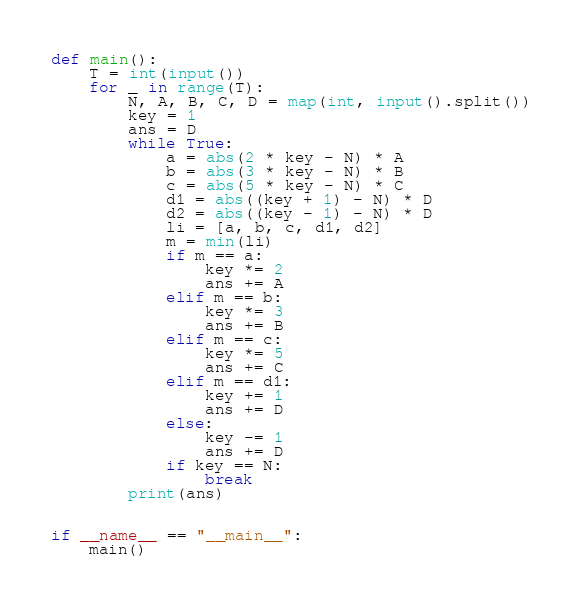<code> <loc_0><loc_0><loc_500><loc_500><_Python_>def main():
    T = int(input())
    for _ in range(T):
        N, A, B, C, D = map(int, input().split())
        key = 1
        ans = D
        while True:
            a = abs(2 * key - N) * A
            b = abs(3 * key - N) * B
            c = abs(5 * key - N) * C
            d1 = abs((key + 1) - N) * D
            d2 = abs((key - 1) - N) * D
            li = [a, b, c, d1, d2]
            m = min(li)
            if m == a:
                key *= 2
                ans += A
            elif m == b:
                key *= 3
                ans += B
            elif m == c:
                key *= 5
                ans += C
            elif m == d1:
                key += 1
                ans += D
            else:
                key -= 1
                ans += D
            if key == N:
                break
        print(ans)


if __name__ == "__main__":
    main()
</code> 